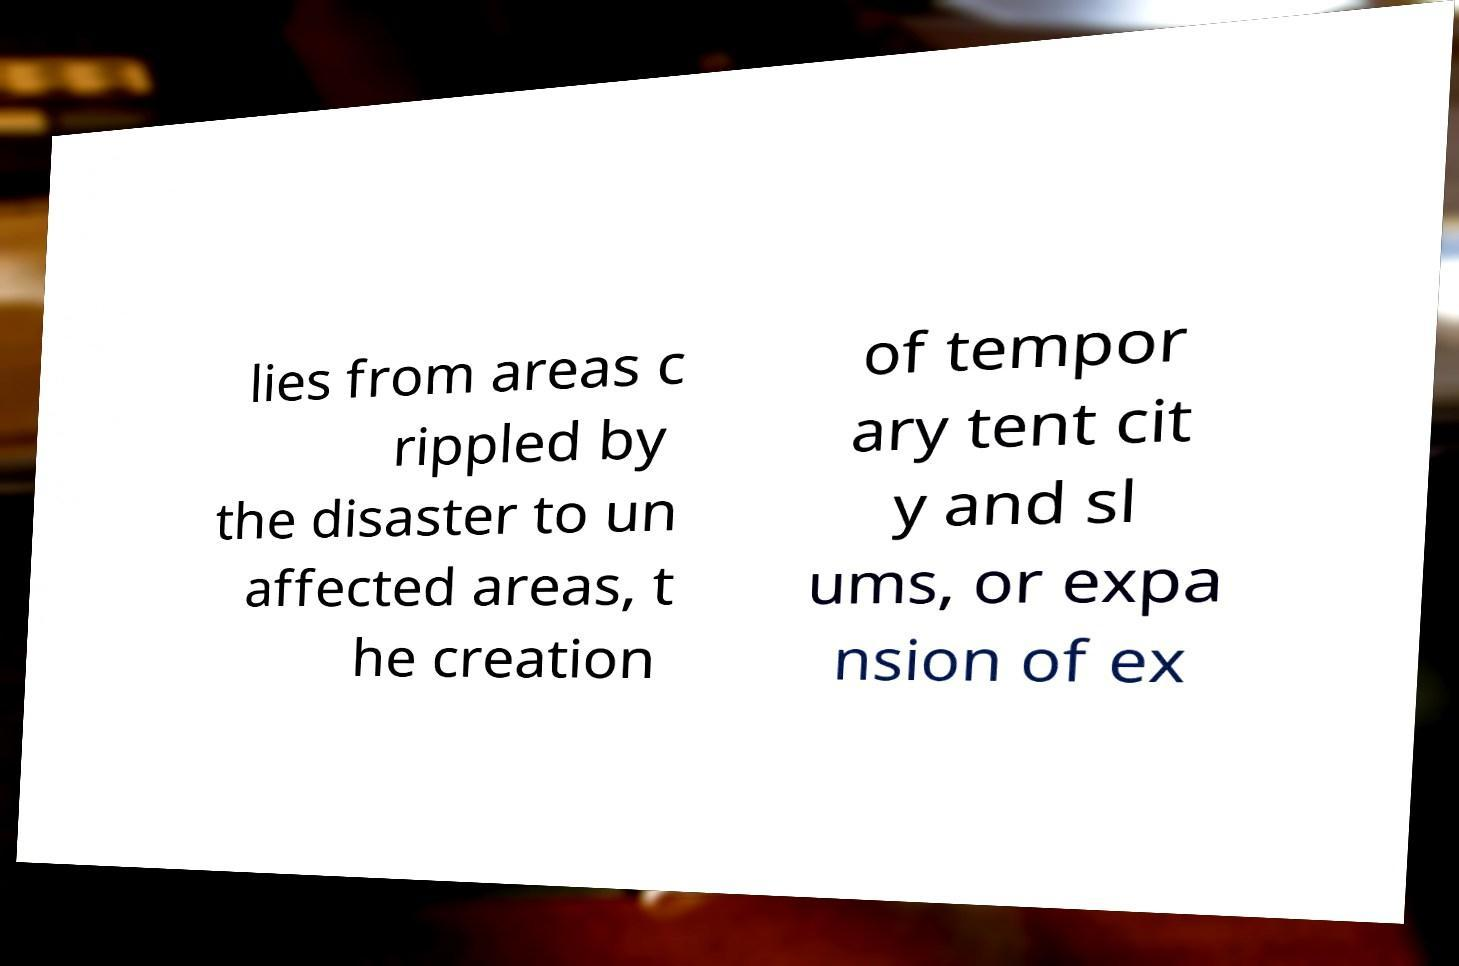Please read and relay the text visible in this image. What does it say? lies from areas c rippled by the disaster to un affected areas, t he creation of tempor ary tent cit y and sl ums, or expa nsion of ex 